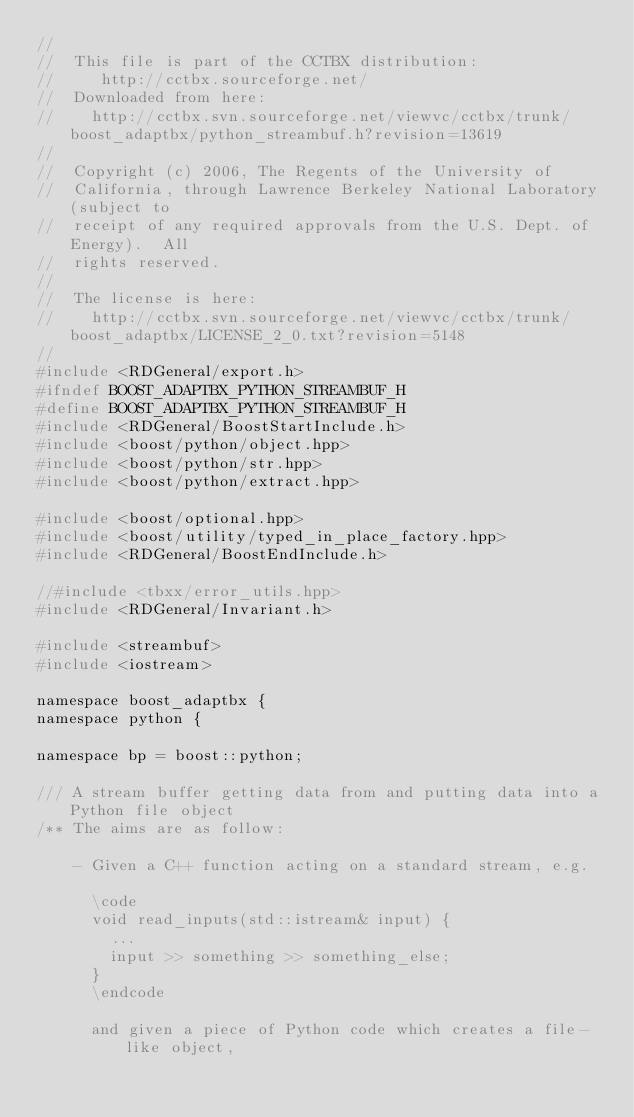Convert code to text. <code><loc_0><loc_0><loc_500><loc_500><_C_>//
//  This file is part of the CCTBX distribution:
//     http://cctbx.sourceforge.net/
//  Downloaded from here:
//    http://cctbx.svn.sourceforge.net/viewvc/cctbx/trunk/boost_adaptbx/python_streambuf.h?revision=13619
//
//  Copyright (c) 2006, The Regents of the University of
//  California, through Lawrence Berkeley National Laboratory (subject to
//  receipt of any required approvals from the U.S. Dept. of Energy).  All
//  rights reserved.
//
//  The license is here:
//    http://cctbx.svn.sourceforge.net/viewvc/cctbx/trunk/boost_adaptbx/LICENSE_2_0.txt?revision=5148
//
#include <RDGeneral/export.h>
#ifndef BOOST_ADAPTBX_PYTHON_STREAMBUF_H
#define BOOST_ADAPTBX_PYTHON_STREAMBUF_H
#include <RDGeneral/BoostStartInclude.h>
#include <boost/python/object.hpp>
#include <boost/python/str.hpp>
#include <boost/python/extract.hpp>

#include <boost/optional.hpp>
#include <boost/utility/typed_in_place_factory.hpp>
#include <RDGeneral/BoostEndInclude.h>

//#include <tbxx/error_utils.hpp>
#include <RDGeneral/Invariant.h>

#include <streambuf>
#include <iostream>

namespace boost_adaptbx {
namespace python {

namespace bp = boost::python;

/// A stream buffer getting data from and putting data into a Python file object
/** The aims are as follow:

    - Given a C++ function acting on a standard stream, e.g.

      \code
      void read_inputs(std::istream& input) {
        ...
        input >> something >> something_else;
      }
      \endcode

      and given a piece of Python code which creates a file-like object,</code> 